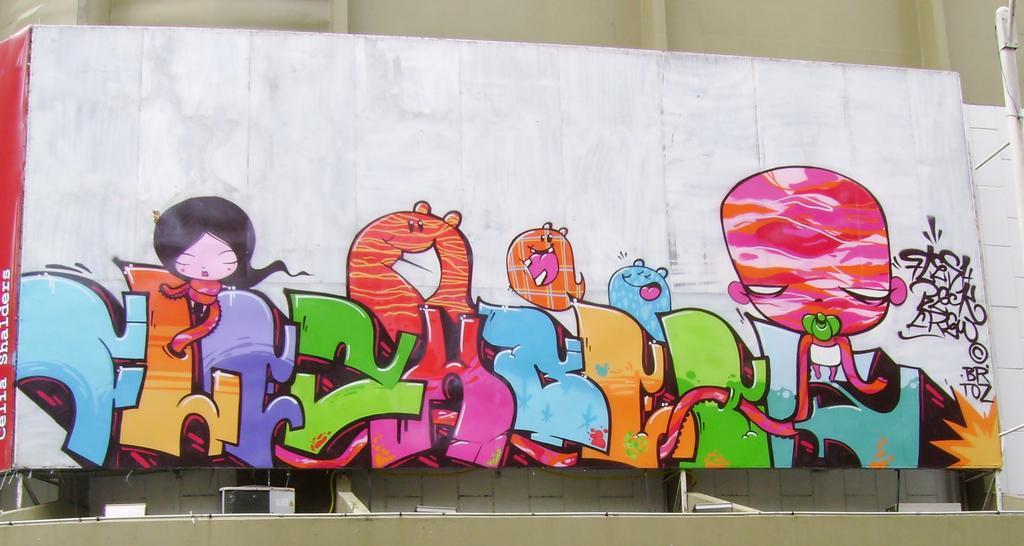In one or two sentences, can you explain what this image depicts? In the center of the image there is a painting on the wall 